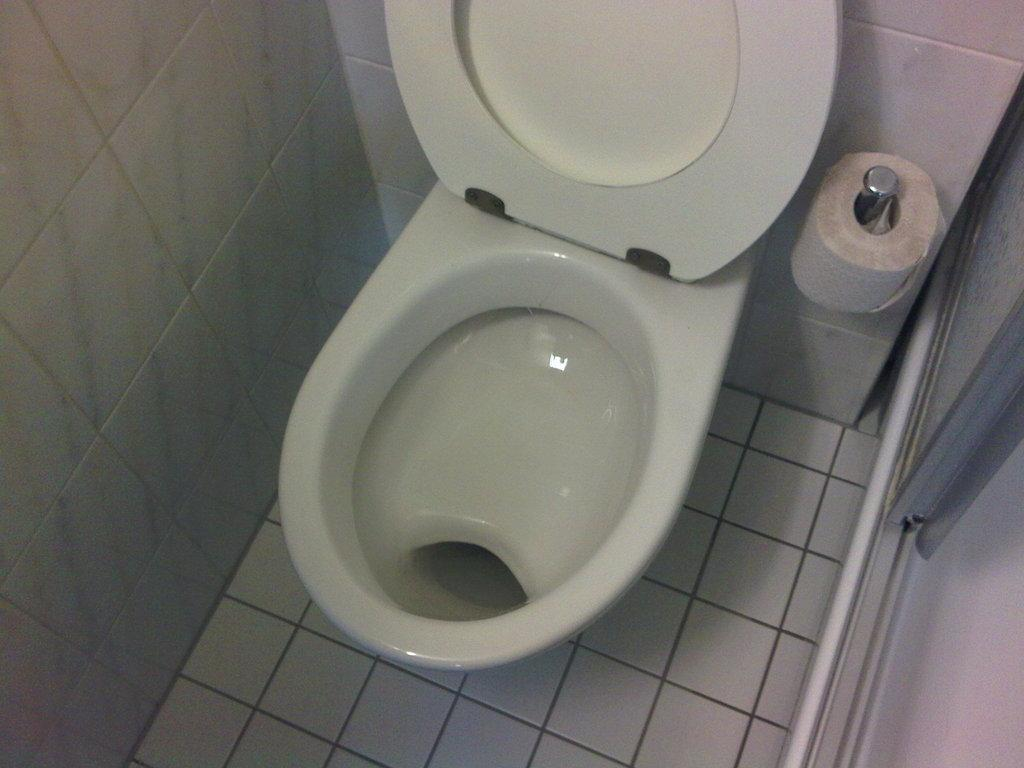What type of room is the image likely taken in? The image was likely taken in a washroom. What can be seen on the toilet in the image? There is a toilet seat in the image. What is available for wiping or blowing one's nose in the image? There is a tissue paper roll in the image. What is the wall material in the image? The walls have tiles. Is there a way to enter or exit the room in the image? Yes, there is a door in the image. How many girls are sitting on the coach in the image? There are no girls or coaches present in the image; it is a washroom setting. 